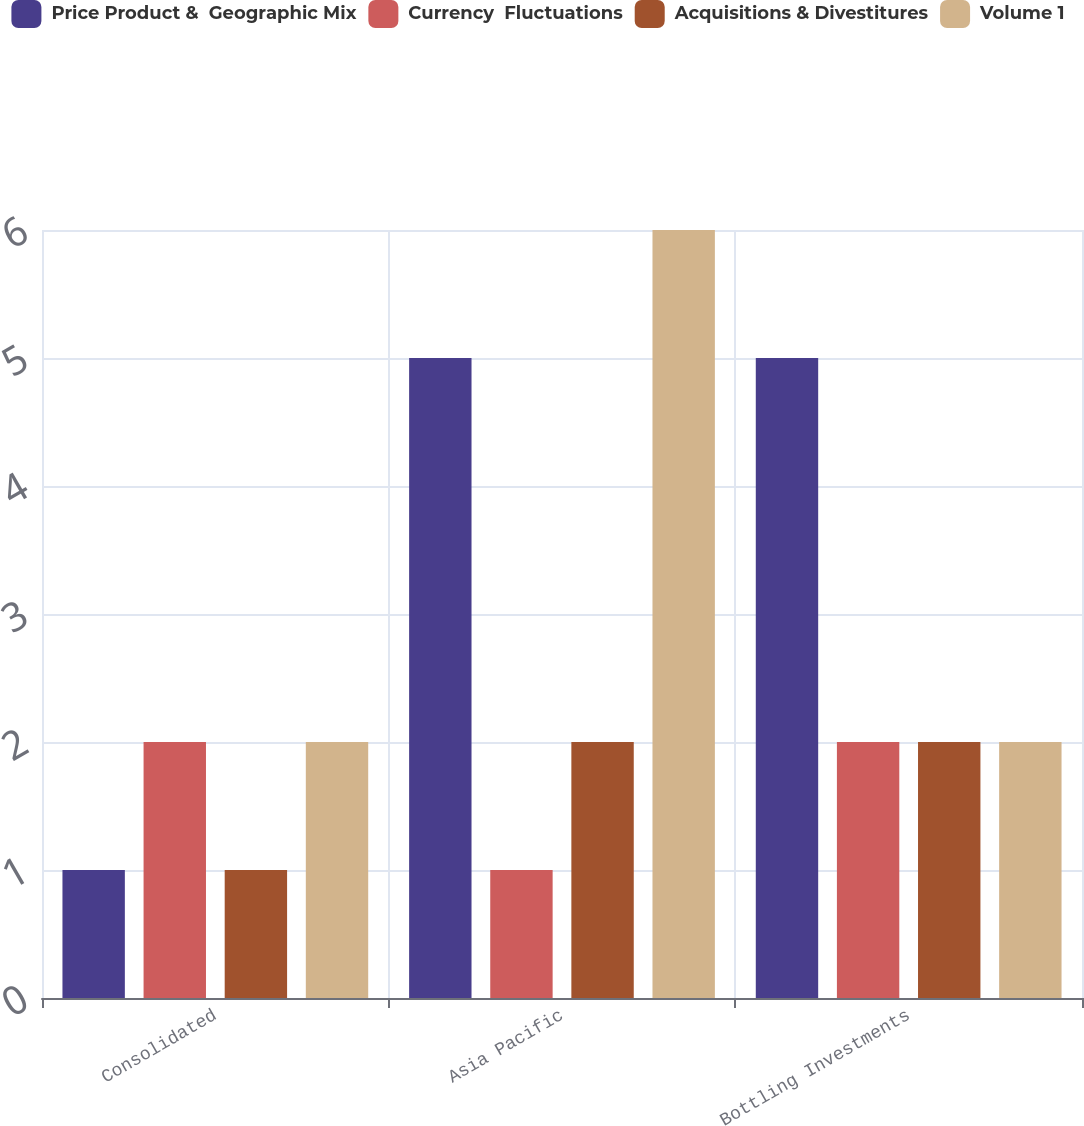Convert chart to OTSL. <chart><loc_0><loc_0><loc_500><loc_500><stacked_bar_chart><ecel><fcel>Consolidated<fcel>Asia Pacific<fcel>Bottling Investments<nl><fcel>Price Product &  Geographic Mix<fcel>1<fcel>5<fcel>5<nl><fcel>Currency  Fluctuations<fcel>2<fcel>1<fcel>2<nl><fcel>Acquisitions & Divestitures<fcel>1<fcel>2<fcel>2<nl><fcel>Volume 1<fcel>2<fcel>6<fcel>2<nl></chart> 